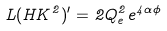<formula> <loc_0><loc_0><loc_500><loc_500>L ( H K ^ { 2 } ) ^ { \prime } = 2 Q _ { e } ^ { 2 } e ^ { 4 \alpha \phi }</formula> 